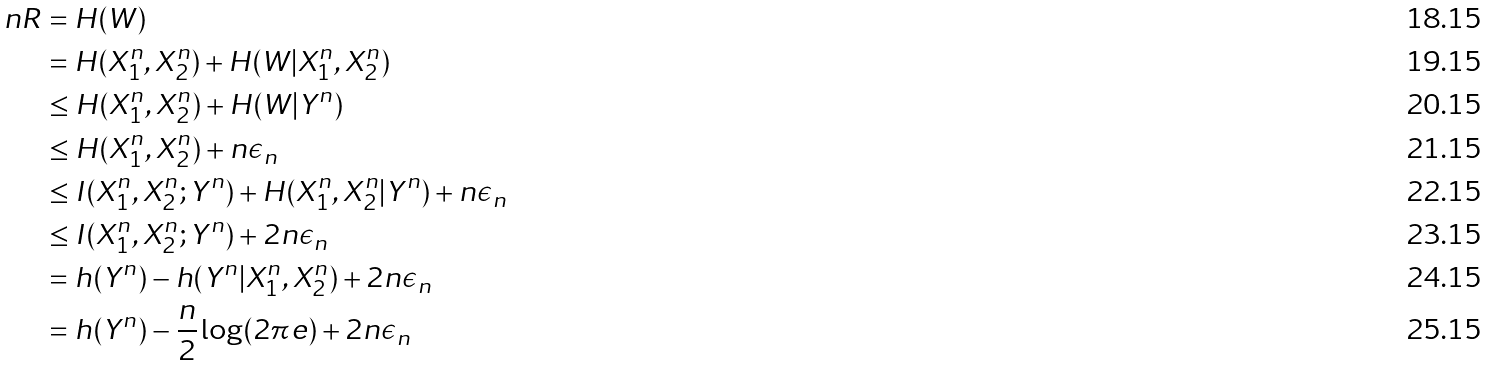<formula> <loc_0><loc_0><loc_500><loc_500>n R & = H ( W ) \\ & = H ( X _ { 1 } ^ { n } , X _ { 2 } ^ { n } ) + H ( W | X _ { 1 } ^ { n } , X _ { 2 } ^ { n } ) \\ & \leq H ( X _ { 1 } ^ { n } , X _ { 2 } ^ { n } ) + H ( W | Y ^ { n } ) \\ & \leq H ( X _ { 1 } ^ { n } , X _ { 2 } ^ { n } ) + n \epsilon _ { n } \\ & \leq I ( X _ { 1 } ^ { n } , X _ { 2 } ^ { n } ; Y ^ { n } ) + H ( X _ { 1 } ^ { n } , X _ { 2 } ^ { n } | Y ^ { n } ) + n \epsilon _ { n } \\ & \leq I ( X _ { 1 } ^ { n } , X _ { 2 } ^ { n } ; Y ^ { n } ) + 2 n \epsilon _ { n } \\ & = h ( Y ^ { n } ) - h ( Y ^ { n } | X _ { 1 } ^ { n } , X _ { 2 } ^ { n } ) + 2 n \epsilon _ { n } \\ & = h ( Y ^ { n } ) - \frac { n } { 2 } \log ( 2 \pi e ) + 2 n \epsilon _ { n }</formula> 